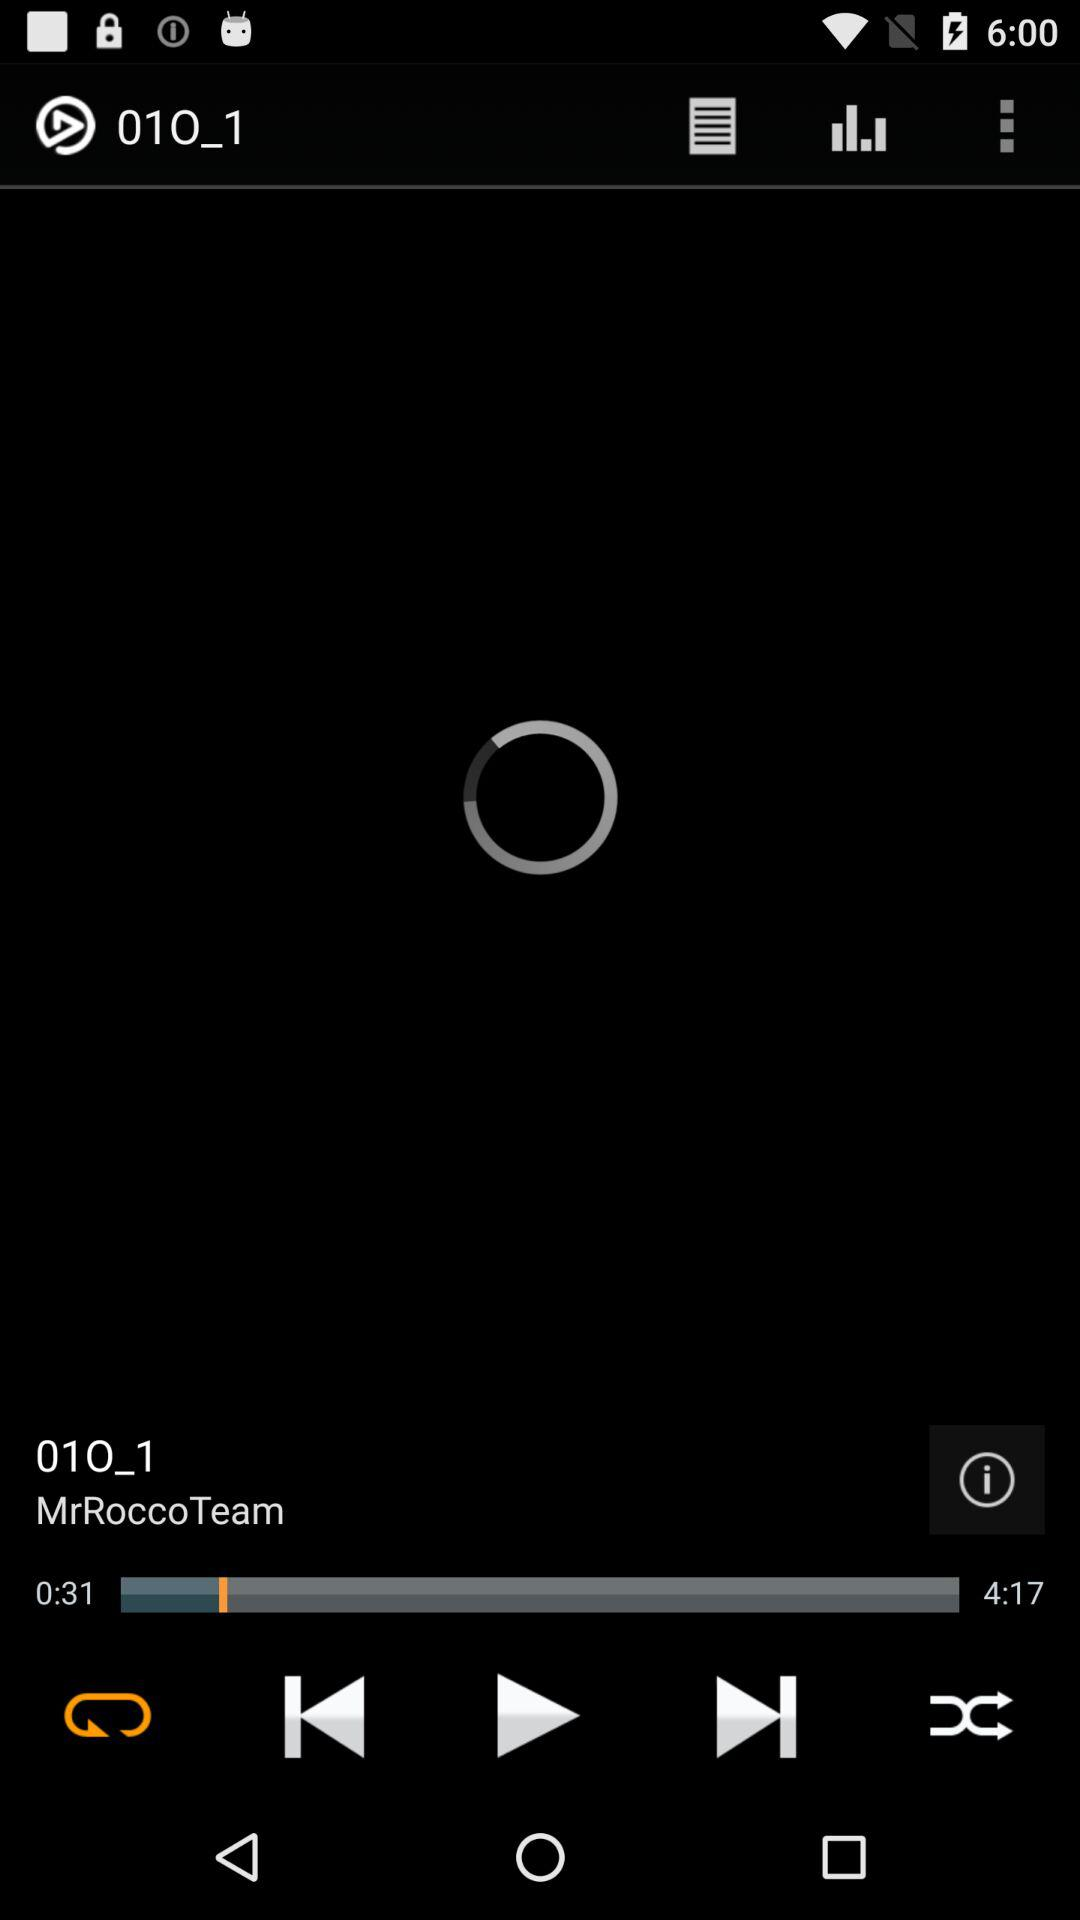Who is the singer of the audio? The singer of the audio is "MrRoccoTeam". 